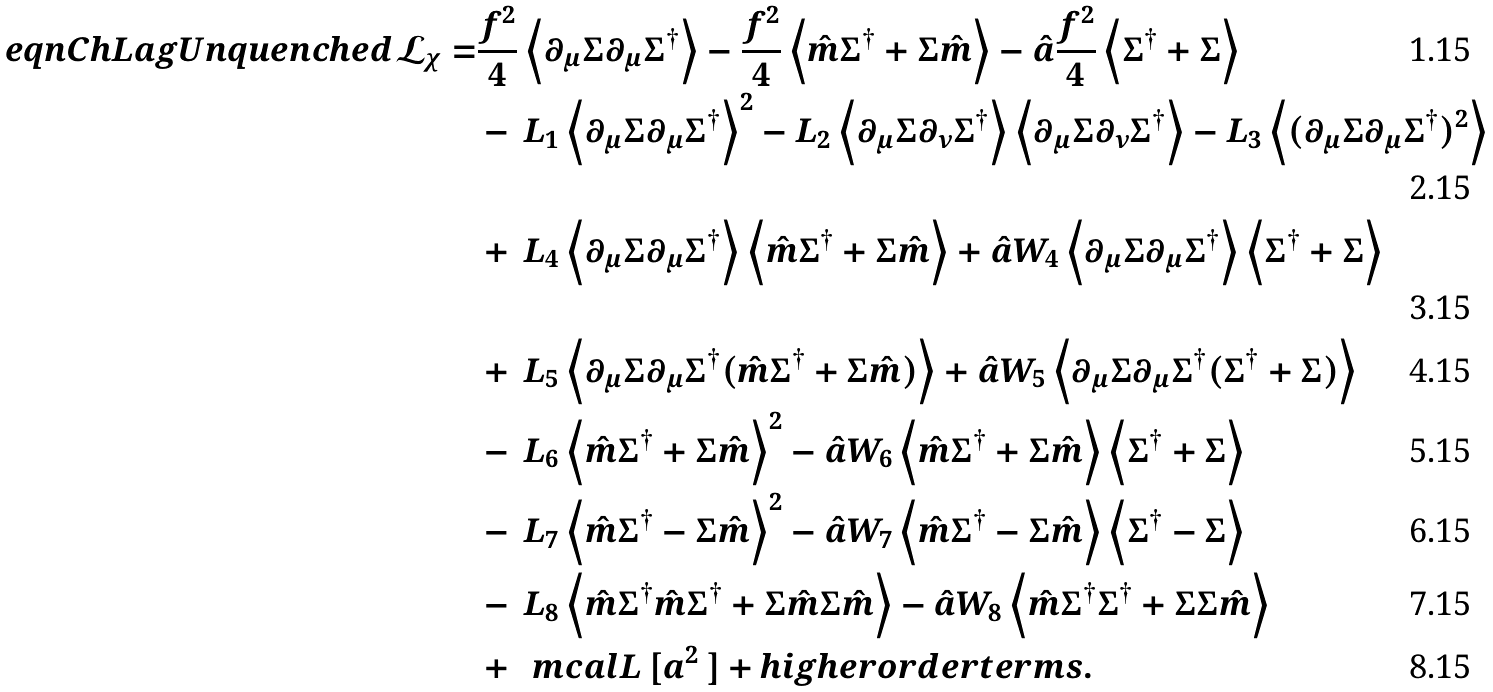<formula> <loc_0><loc_0><loc_500><loc_500>\ e q n { C h L a g U n q u e n c h e d } \mathcal { L } _ { \chi } = & \frac { f ^ { 2 } } { 4 } \left \langle \partial _ { \mu } \Sigma \partial _ { \mu } \Sigma ^ { \dag } \right \rangle - \frac { f ^ { 2 } } { 4 } \left \langle \hat { m } \Sigma ^ { \dag } + \Sigma \hat { m } \right \rangle - \hat { a } \frac { f ^ { 2 } } { 4 } \left \langle \Sigma ^ { \dag } + \Sigma \right \rangle \\ & - \, { L _ { 1 } \left \langle { \partial _ { \mu } \Sigma \partial _ { \mu } \Sigma ^ { \dag } } \right \rangle ^ { 2 } } - { L _ { 2 } \left \langle { \partial _ { \mu } \Sigma \partial _ { \nu } \Sigma ^ { \dag } } \right \rangle \left \langle { \partial _ { \mu } \Sigma \partial _ { \nu } \Sigma ^ { \dag } } \right \rangle } - { L _ { 3 } \left \langle { ( \partial _ { \mu } \Sigma \partial _ { \mu } \Sigma ^ { \dag } ) ^ { 2 } } \right \rangle } \\ & + \, { L _ { 4 } \left \langle { \partial _ { \mu } \Sigma \partial _ { \mu } \Sigma ^ { \dag } } \right \rangle \left \langle { \hat { m } \Sigma ^ { \dag } + \Sigma \hat { m } } \right \rangle } + { \hat { a } W _ { 4 } \left \langle { \partial _ { \mu } \Sigma \partial _ { \mu } \Sigma ^ { \dag } } \right \rangle \left \langle { \Sigma ^ { \dag } + \Sigma } \right \rangle } \\ & + \, { L _ { 5 } \left \langle { \partial _ { \mu } \Sigma \partial _ { \mu } \Sigma ^ { \dag } ( \hat { m } \Sigma ^ { \dag } + \Sigma \hat { m } ) } \right \rangle } + { \hat { a } W _ { 5 } \left \langle { \partial _ { \mu } \Sigma \partial _ { \mu } \Sigma ^ { \dag } ( \Sigma ^ { \dag } + \Sigma ) } \right \rangle } \\ & - \, { L _ { 6 } \left \langle { \hat { m } \Sigma ^ { \dag } + \Sigma \hat { m } } \right \rangle ^ { 2 } } - { \hat { a } W _ { 6 } \left \langle { \hat { m } \Sigma ^ { \dag } + \Sigma \hat { m } } \right \rangle \left \langle { \Sigma ^ { \dag } + \Sigma } \right \rangle } \\ & - \, { L _ { 7 } \left \langle { \hat { m } \Sigma ^ { \dag } - \Sigma \hat { m } } \right \rangle ^ { 2 } } - { \hat { a } W _ { 7 } \left \langle { \hat { m } \Sigma ^ { \dag } - \Sigma \hat { m } } \right \rangle \left \langle { \Sigma ^ { \dag } - \Sigma } \right \rangle } \\ & - \, { L _ { 8 } \left \langle { \hat { m } \Sigma ^ { \dag } \hat { m } \Sigma ^ { \dag } + \Sigma \hat { m } \Sigma \hat { m } } \right \rangle } - { \hat { a } W _ { 8 } \left \langle { \hat { m } \Sigma ^ { \dag } \Sigma ^ { \dag } + \Sigma \Sigma \hat { m } } \right \rangle } \\ & + \, \ m c a l L \ [ a ^ { 2 } \ ] + h i g h e r o r d e r t e r m s .</formula> 